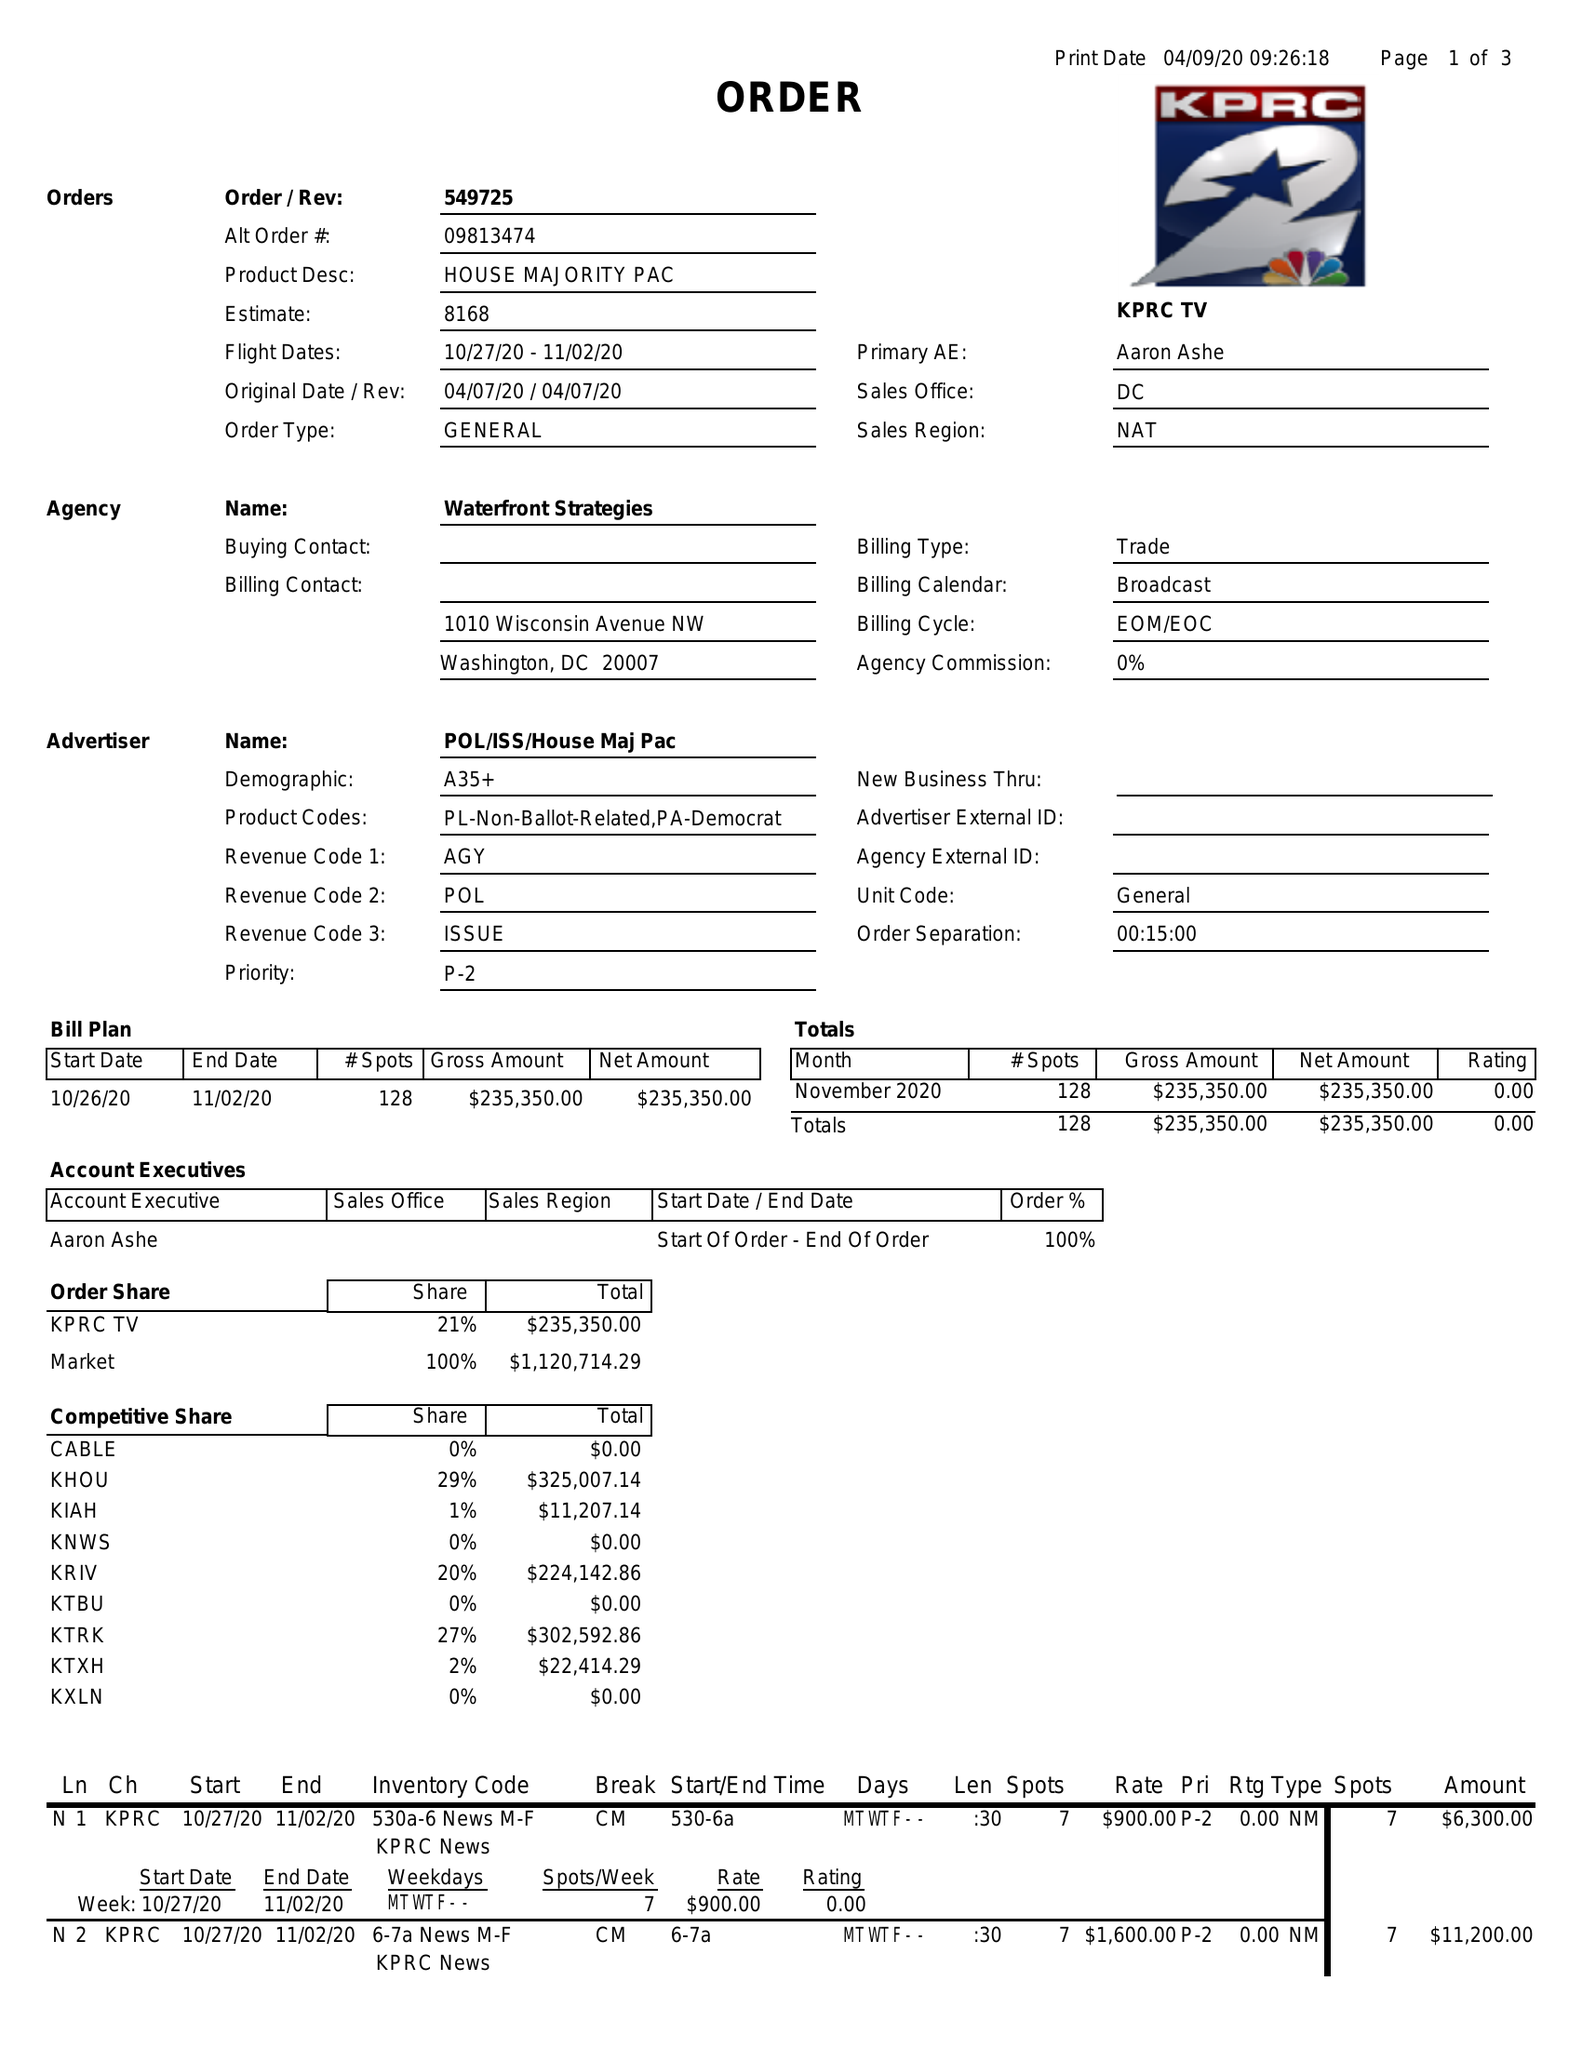What is the value for the gross_amount?
Answer the question using a single word or phrase. 235350.00 